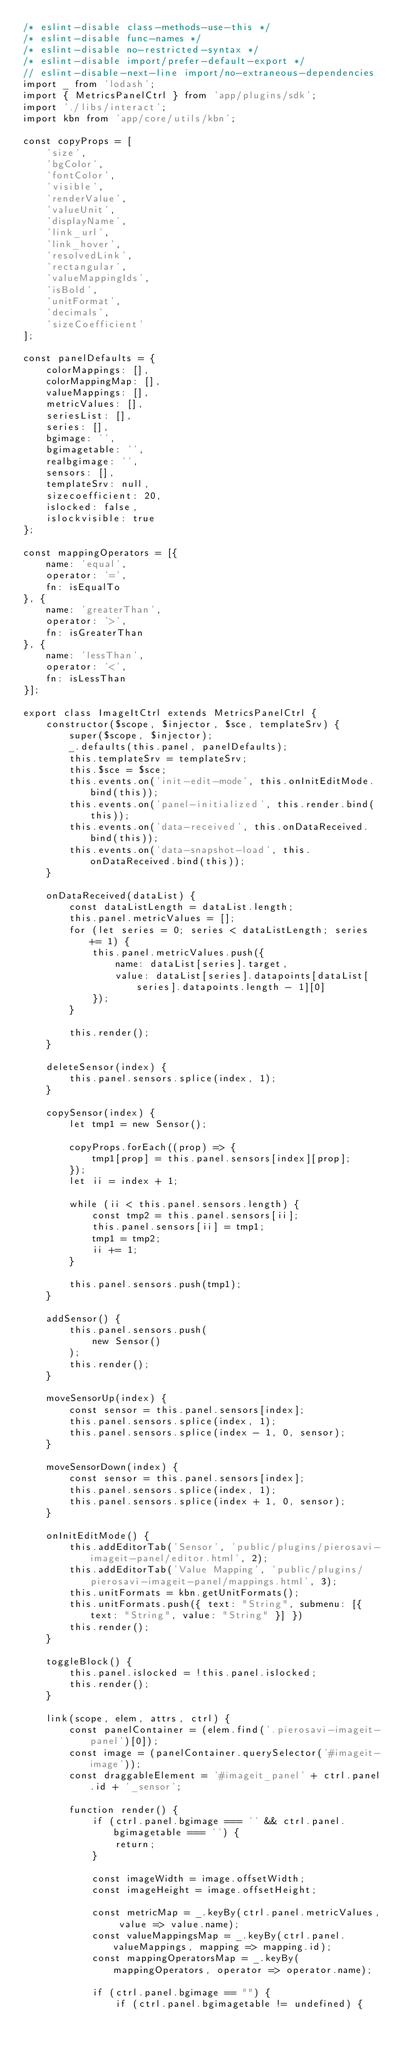<code> <loc_0><loc_0><loc_500><loc_500><_JavaScript_>/* eslint-disable class-methods-use-this */
/* eslint-disable func-names */
/* eslint-disable no-restricted-syntax */
/* eslint-disable import/prefer-default-export */
// eslint-disable-next-line import/no-extraneous-dependencies
import _ from 'lodash';
import { MetricsPanelCtrl } from 'app/plugins/sdk';
import './libs/interact';
import kbn from 'app/core/utils/kbn';

const copyProps = [
    'size',
    'bgColor',
    'fontColor',
    'visible',
    'renderValue',
    'valueUnit',
    'displayName',
    'link_url',
    'link_hover',
    'resolvedLink',
    'rectangular',
    'valueMappingIds',
    'isBold',
    'unitFormat',
    'decimals',
    'sizeCoefficient'
];

const panelDefaults = {
    colorMappings: [],
    colorMappingMap: [],
    valueMappings: [],
    metricValues: [],
    seriesList: [],
    series: [],
    bgimage: '',
    bgimagetable: '',
    realbgimage: '',
    sensors: [],
    templateSrv: null,
    sizecoefficient: 20,
    islocked: false,
    islockvisible: true
};

const mappingOperators = [{
    name: 'equal',
    operator: '=',
    fn: isEqualTo
}, {
    name: 'greaterThan',
    operator: '>',
    fn: isGreaterThan
}, {
    name: 'lessThan',
    operator: '<',
    fn: isLessThan
}];

export class ImageItCtrl extends MetricsPanelCtrl {
    constructor($scope, $injector, $sce, templateSrv) {
        super($scope, $injector);
        _.defaults(this.panel, panelDefaults);
        this.templateSrv = templateSrv;
        this.$sce = $sce;
        this.events.on('init-edit-mode', this.onInitEditMode.bind(this));
        this.events.on('panel-initialized', this.render.bind(this));
        this.events.on('data-received', this.onDataReceived.bind(this));
        this.events.on('data-snapshot-load', this.onDataReceived.bind(this));
    }

    onDataReceived(dataList) {
        const dataListLength = dataList.length;
        this.panel.metricValues = [];
        for (let series = 0; series < dataListLength; series += 1) {
            this.panel.metricValues.push({
                name: dataList[series].target,
                value: dataList[series].datapoints[dataList[series].datapoints.length - 1][0]
            });
        }

        this.render();
    }

    deleteSensor(index) {
        this.panel.sensors.splice(index, 1);
    }

    copySensor(index) {
        let tmp1 = new Sensor();

        copyProps.forEach((prop) => {
            tmp1[prop] = this.panel.sensors[index][prop];
        });
        let ii = index + 1;

        while (ii < this.panel.sensors.length) {
            const tmp2 = this.panel.sensors[ii];
            this.panel.sensors[ii] = tmp1;
            tmp1 = tmp2;
            ii += 1;
        }

        this.panel.sensors.push(tmp1);
    }

    addSensor() {
        this.panel.sensors.push(
            new Sensor()
        );
        this.render();
    }

    moveSensorUp(index) {
        const sensor = this.panel.sensors[index];
        this.panel.sensors.splice(index, 1);
        this.panel.sensors.splice(index - 1, 0, sensor);
    }

    moveSensorDown(index) {
        const sensor = this.panel.sensors[index];
        this.panel.sensors.splice(index, 1);
        this.panel.sensors.splice(index + 1, 0, sensor);
    }

    onInitEditMode() {
        this.addEditorTab('Sensor', 'public/plugins/pierosavi-imageit-panel/editor.html', 2);
        this.addEditorTab('Value Mapping', 'public/plugins/pierosavi-imageit-panel/mappings.html', 3);
        this.unitFormats = kbn.getUnitFormats();
        this.unitFormats.push({ text: "String", submenu: [{ text: "String", value: "String" }] })
        this.render();
    }

    toggleBlock() {
        this.panel.islocked = !this.panel.islocked;
        this.render();
    }

    link(scope, elem, attrs, ctrl) {
        const panelContainer = (elem.find('.pierosavi-imageit-panel')[0]);
        const image = (panelContainer.querySelector('#imageit-image'));
        const draggableElement = '#imageit_panel' + ctrl.panel.id + '_sensor';

        function render() {
            if (ctrl.panel.bgimage === '' && ctrl.panel.bgimagetable === '') {
                return;
            }

            const imageWidth = image.offsetWidth;
            const imageHeight = image.offsetHeight;

            const metricMap = _.keyBy(ctrl.panel.metricValues, value => value.name);
            const valueMappingsMap = _.keyBy(ctrl.panel.valueMappings, mapping => mapping.id);
            const mappingOperatorsMap = _.keyBy(mappingOperators, operator => operator.name);

            if (ctrl.panel.bgimage == "") {
                if (ctrl.panel.bgimagetable != undefined) {</code> 